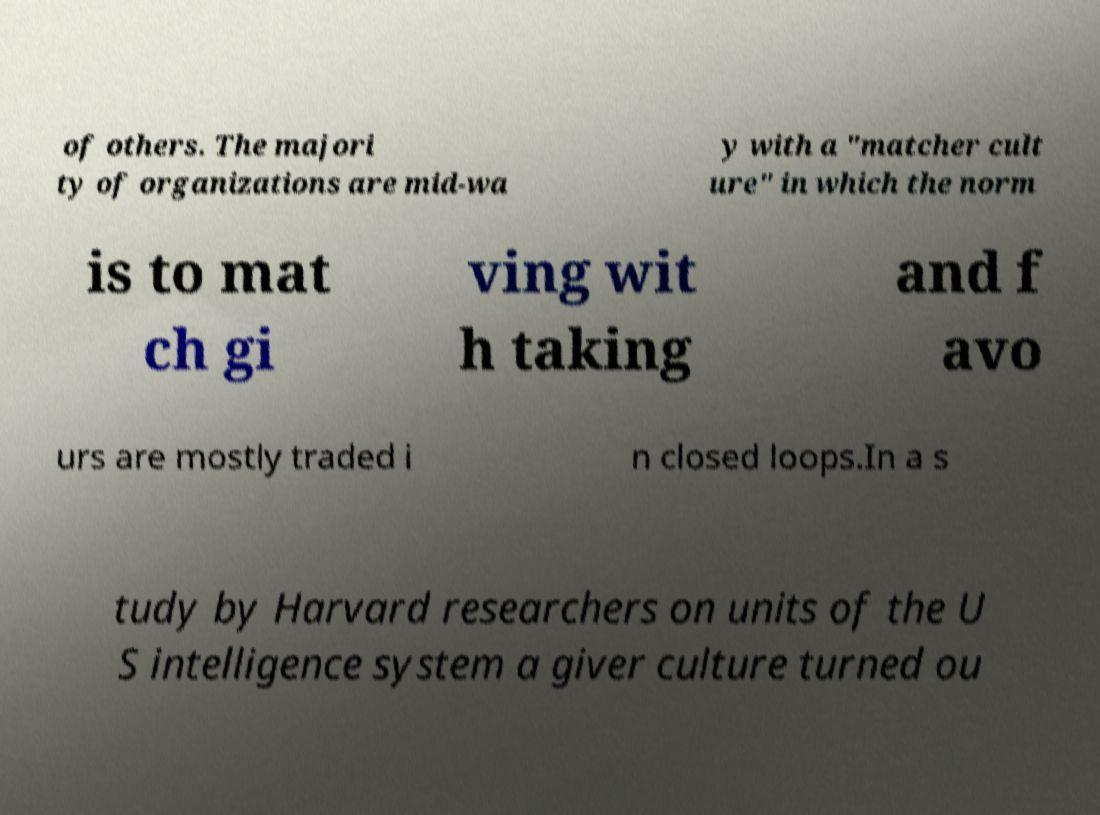There's text embedded in this image that I need extracted. Can you transcribe it verbatim? of others. The majori ty of organizations are mid-wa y with a "matcher cult ure" in which the norm is to mat ch gi ving wit h taking and f avo urs are mostly traded i n closed loops.In a s tudy by Harvard researchers on units of the U S intelligence system a giver culture turned ou 